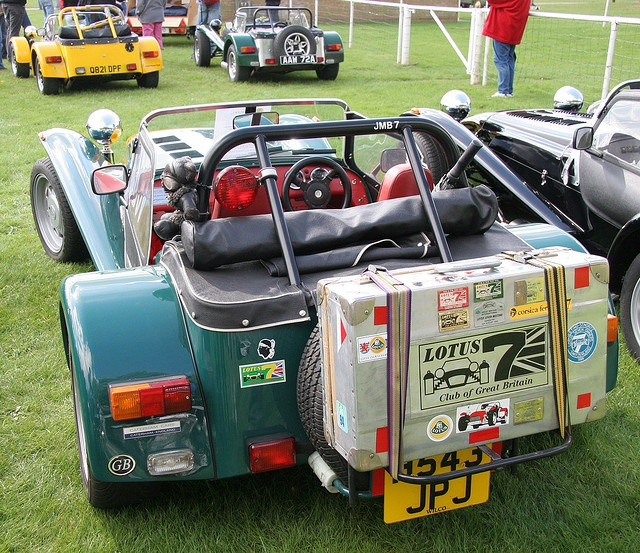Describe the objects in this image and their specific colors. I can see car in darkgray, black, lightgray, and gray tones, suitcase in darkgray, lightgray, olive, and black tones, car in darkgray, black, white, and gray tones, car in gray, black, and gold tones, and car in gray, darkgray, lightgray, and black tones in this image. 